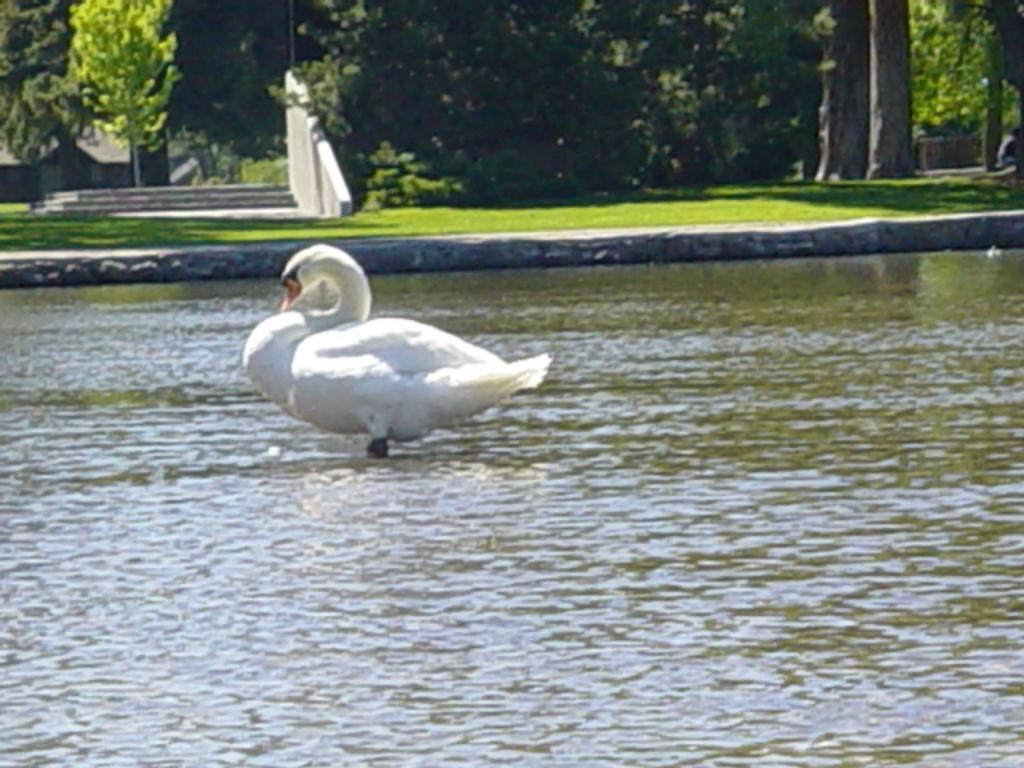What animal is in the water in the image? There is a swan in the water in the image. What type of vegetation can be seen in the image? There are trees visible in the image. What architectural feature is present in the image? There is a wall in the image. What can be used for walking up or down in the image? There are steps in the image. What type of ground surface is visible in the image? There is grass in the image. What structure might be located behind the trees in the image? There appears to be a house behind the trees in the image. What part of the swan's body is holding a hand in the image? There is no hand or any human interaction with the swan in the image. What type of cable can be seen connecting the trees in the image? There are no cables visible connecting the trees in the image. 